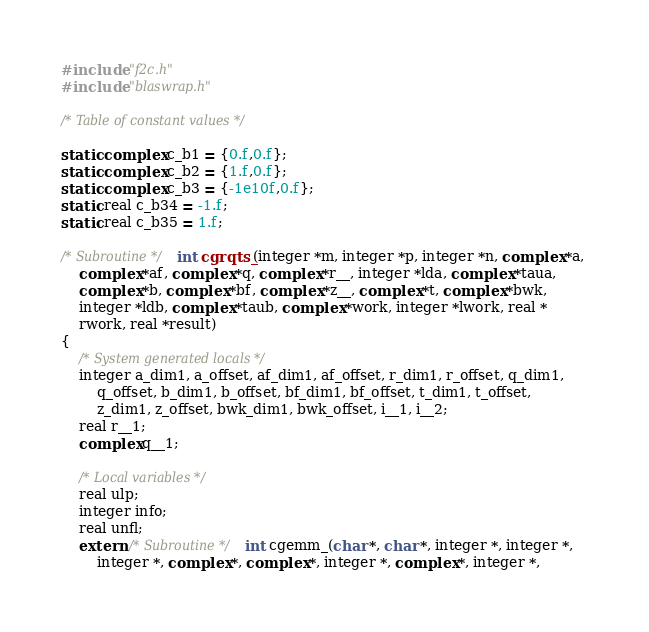Convert code to text. <code><loc_0><loc_0><loc_500><loc_500><_C_>#include "f2c.h"
#include "blaswrap.h"

/* Table of constant values */

static complex c_b1 = {0.f,0.f};
static complex c_b2 = {1.f,0.f};
static complex c_b3 = {-1e10f,0.f};
static real c_b34 = -1.f;
static real c_b35 = 1.f;

/* Subroutine */ int cgrqts_(integer *m, integer *p, integer *n, complex *a, 
	complex *af, complex *q, complex *r__, integer *lda, complex *taua, 
	complex *b, complex *bf, complex *z__, complex *t, complex *bwk, 
	integer *ldb, complex *taub, complex *work, integer *lwork, real *
	rwork, real *result)
{
    /* System generated locals */
    integer a_dim1, a_offset, af_dim1, af_offset, r_dim1, r_offset, q_dim1, 
	    q_offset, b_dim1, b_offset, bf_dim1, bf_offset, t_dim1, t_offset, 
	    z_dim1, z_offset, bwk_dim1, bwk_offset, i__1, i__2;
    real r__1;
    complex q__1;

    /* Local variables */
    real ulp;
    integer info;
    real unfl;
    extern /* Subroutine */ int cgemm_(char *, char *, integer *, integer *, 
	    integer *, complex *, complex *, integer *, complex *, integer *, </code> 